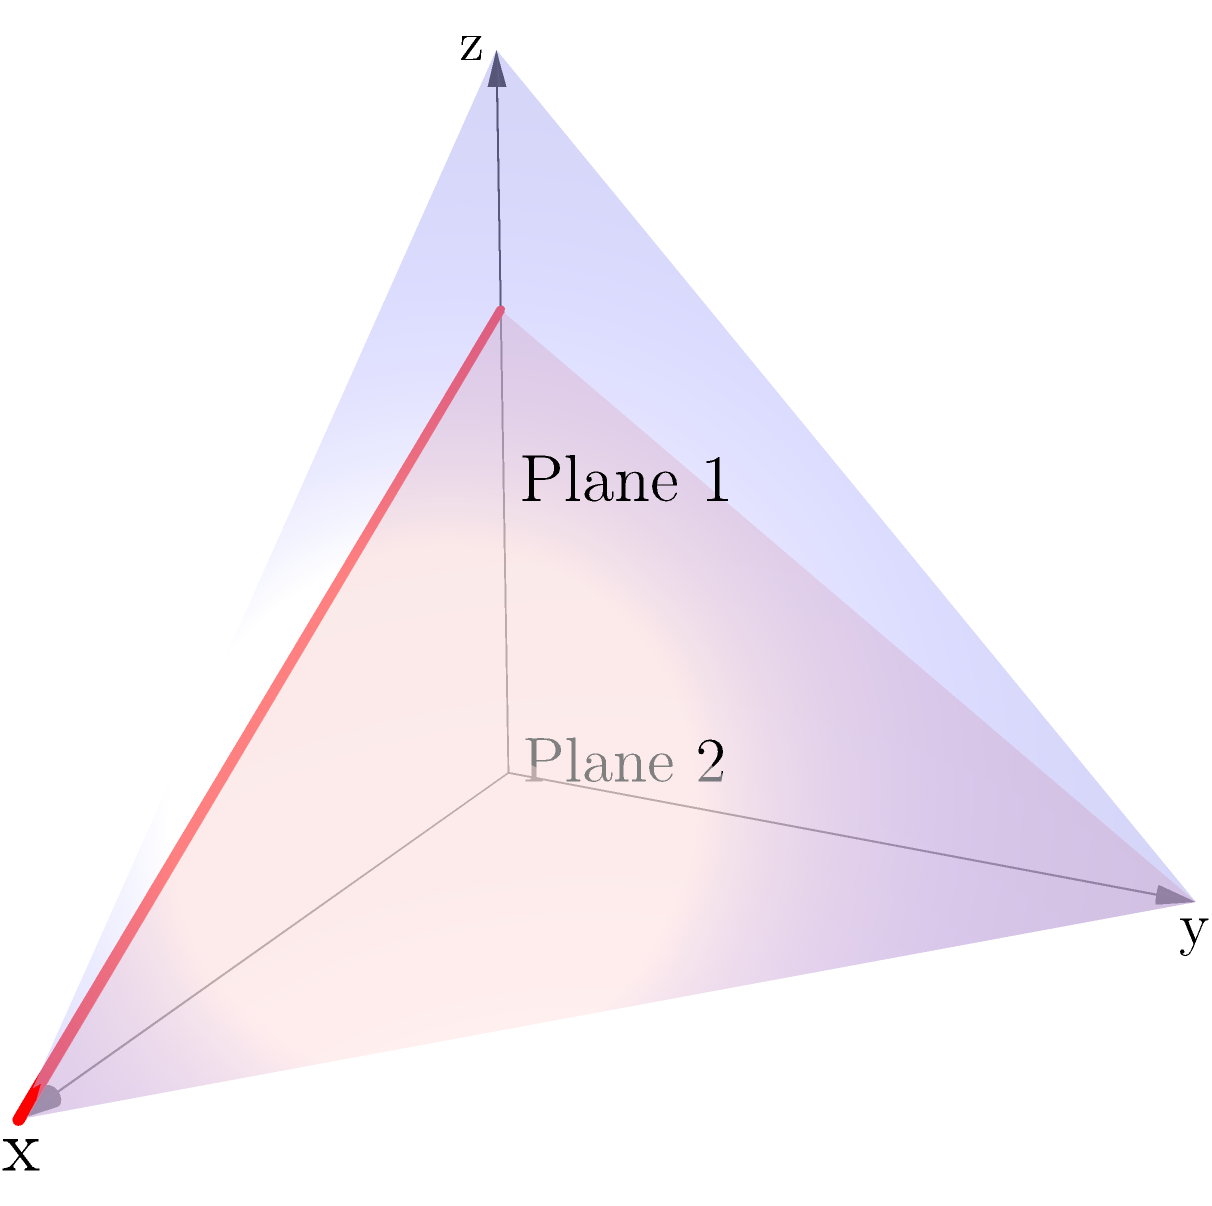In an organ-on-chip device, two microfluidic channels need to intersect at a specific angle to optimize cell culture conditions. The channels can be represented by two planes in a 3D coordinate system:

Plane 1: $x + y + z = 6$
Plane 2: $z = 4 - x$

Find the equation of the line of intersection between these two planes. How can this information be used to optimize the placement of cells in the organ-on-chip device? To find the line of intersection between the two planes, we'll follow these steps:

1) First, we need to find two points that satisfy both plane equations. We can do this by choosing arbitrary x and y values and solving for z.

2) For Plane 1: $x + y + z = 6$
   For Plane 2: $z = 4 - x$

3) Let's find the first point by setting $x = 0$:
   Plane 2: $z = 4 - 0 = 4$
   Plane 1: $0 + y + 4 = 6$, so $y = 2$
   First point: $(0, 2, 4)$

4) For the second point, let's set $x = 4$:
   Plane 2: $z = 4 - 4 = 0$
   Plane 1: $4 + y + 0 = 6$, so $y = 2$
   Second point: $(4, 2, 0)$

5) Now we have two points on the line of intersection: $(0, 2, 4)$ and $(4, 2, 0)$

6) The direction vector of the line is the difference between these points:
   $\vec{v} = (4-0, 2-2, 0-4) = (4, 0, -4)$

7) We can simplify this to $(1, 0, -1)$

8) The equation of the line can be written in parametric form:
   $x = t$
   $y = 2$
   $z = 4 - t$

9) This information can be used to optimize cell placement in the organ-on-chip device by:
   a) Ensuring that cells are placed along this line of intersection for maximum exposure to both microfluidic channels.
   b) Adjusting the angle of intersection by modifying the plane equations to create optimal flow conditions for specific cell types.
   c) Using the y-coordinate (constant at 2) to determine the ideal width of the cell culture area.
   d) Utilizing the relationship between x and z coordinates to design gradient-based experiments along the length of the intersection.
Answer: Line equation: $x = t$, $y = 2$, $z = 4 - t$; Optimize by placing cells along intersection, adjusting angle, width, and gradients. 